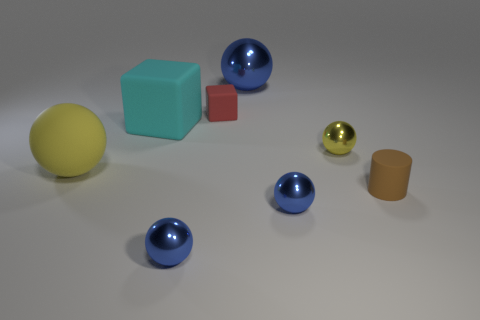Subtract all small metal spheres. How many spheres are left? 2 Add 2 blue spheres. How many objects exist? 10 Subtract all cubes. How many objects are left? 6 Subtract 4 spheres. How many spheres are left? 1 Subtract all green balls. How many blue blocks are left? 0 Subtract all large balls. Subtract all small yellow metal things. How many objects are left? 5 Add 2 small brown rubber cylinders. How many small brown rubber cylinders are left? 3 Add 6 tiny blue spheres. How many tiny blue spheres exist? 8 Subtract all cyan blocks. How many blocks are left? 1 Subtract 0 red balls. How many objects are left? 8 